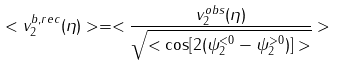<formula> <loc_0><loc_0><loc_500><loc_500>< v _ { 2 } ^ { b , r e c } ( \eta ) > = < \frac { v _ { 2 } ^ { o b s } ( \eta ) } { \sqrt { < \cos [ 2 ( \psi _ { 2 } ^ { < 0 } - \psi _ { 2 } ^ { > 0 } ) ] > } } ></formula> 